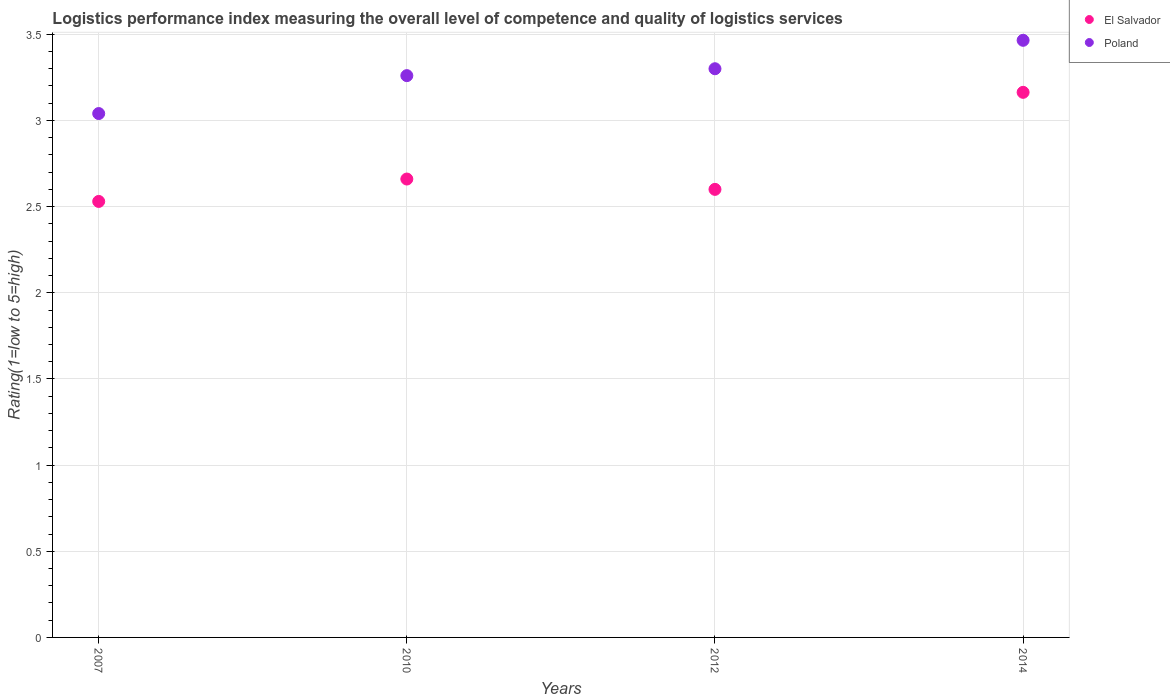Is the number of dotlines equal to the number of legend labels?
Ensure brevity in your answer.  Yes. What is the Logistic performance index in El Salvador in 2007?
Your response must be concise. 2.53. Across all years, what is the maximum Logistic performance index in Poland?
Provide a short and direct response. 3.47. Across all years, what is the minimum Logistic performance index in Poland?
Provide a succinct answer. 3.04. In which year was the Logistic performance index in El Salvador maximum?
Your response must be concise. 2014. In which year was the Logistic performance index in El Salvador minimum?
Make the answer very short. 2007. What is the total Logistic performance index in Poland in the graph?
Your answer should be compact. 13.07. What is the difference between the Logistic performance index in Poland in 2007 and that in 2012?
Your answer should be compact. -0.26. What is the difference between the Logistic performance index in El Salvador in 2010 and the Logistic performance index in Poland in 2007?
Your answer should be very brief. -0.38. What is the average Logistic performance index in El Salvador per year?
Your answer should be compact. 2.74. In the year 2014, what is the difference between the Logistic performance index in Poland and Logistic performance index in El Salvador?
Your response must be concise. 0.3. In how many years, is the Logistic performance index in El Salvador greater than 1.7?
Provide a succinct answer. 4. What is the ratio of the Logistic performance index in El Salvador in 2007 to that in 2014?
Your answer should be very brief. 0.8. Is the Logistic performance index in El Salvador in 2007 less than that in 2012?
Ensure brevity in your answer.  Yes. Is the difference between the Logistic performance index in Poland in 2012 and 2014 greater than the difference between the Logistic performance index in El Salvador in 2012 and 2014?
Your answer should be very brief. Yes. What is the difference between the highest and the second highest Logistic performance index in El Salvador?
Offer a terse response. 0.5. What is the difference between the highest and the lowest Logistic performance index in El Salvador?
Offer a terse response. 0.63. In how many years, is the Logistic performance index in El Salvador greater than the average Logistic performance index in El Salvador taken over all years?
Make the answer very short. 1. Is the sum of the Logistic performance index in Poland in 2010 and 2014 greater than the maximum Logistic performance index in El Salvador across all years?
Keep it short and to the point. Yes. How many dotlines are there?
Your answer should be very brief. 2. How many years are there in the graph?
Offer a terse response. 4. Are the values on the major ticks of Y-axis written in scientific E-notation?
Keep it short and to the point. No. Does the graph contain any zero values?
Offer a very short reply. No. Where does the legend appear in the graph?
Give a very brief answer. Top right. How are the legend labels stacked?
Your answer should be very brief. Vertical. What is the title of the graph?
Your answer should be very brief. Logistics performance index measuring the overall level of competence and quality of logistics services. What is the label or title of the X-axis?
Ensure brevity in your answer.  Years. What is the label or title of the Y-axis?
Keep it short and to the point. Rating(1=low to 5=high). What is the Rating(1=low to 5=high) in El Salvador in 2007?
Your answer should be compact. 2.53. What is the Rating(1=low to 5=high) in Poland in 2007?
Your answer should be very brief. 3.04. What is the Rating(1=low to 5=high) of El Salvador in 2010?
Keep it short and to the point. 2.66. What is the Rating(1=low to 5=high) in Poland in 2010?
Keep it short and to the point. 3.26. What is the Rating(1=low to 5=high) in Poland in 2012?
Offer a very short reply. 3.3. What is the Rating(1=low to 5=high) in El Salvador in 2014?
Provide a short and direct response. 3.16. What is the Rating(1=low to 5=high) of Poland in 2014?
Offer a very short reply. 3.47. Across all years, what is the maximum Rating(1=low to 5=high) in El Salvador?
Give a very brief answer. 3.16. Across all years, what is the maximum Rating(1=low to 5=high) of Poland?
Your answer should be compact. 3.47. Across all years, what is the minimum Rating(1=low to 5=high) of El Salvador?
Keep it short and to the point. 2.53. Across all years, what is the minimum Rating(1=low to 5=high) in Poland?
Ensure brevity in your answer.  3.04. What is the total Rating(1=low to 5=high) of El Salvador in the graph?
Your answer should be compact. 10.95. What is the total Rating(1=low to 5=high) of Poland in the graph?
Your answer should be very brief. 13.06. What is the difference between the Rating(1=low to 5=high) in El Salvador in 2007 and that in 2010?
Give a very brief answer. -0.13. What is the difference between the Rating(1=low to 5=high) in Poland in 2007 and that in 2010?
Ensure brevity in your answer.  -0.22. What is the difference between the Rating(1=low to 5=high) in El Salvador in 2007 and that in 2012?
Give a very brief answer. -0.07. What is the difference between the Rating(1=low to 5=high) of Poland in 2007 and that in 2012?
Your answer should be very brief. -0.26. What is the difference between the Rating(1=low to 5=high) of El Salvador in 2007 and that in 2014?
Provide a short and direct response. -0.63. What is the difference between the Rating(1=low to 5=high) of Poland in 2007 and that in 2014?
Make the answer very short. -0.42. What is the difference between the Rating(1=low to 5=high) in El Salvador in 2010 and that in 2012?
Your answer should be very brief. 0.06. What is the difference between the Rating(1=low to 5=high) of Poland in 2010 and that in 2012?
Your response must be concise. -0.04. What is the difference between the Rating(1=low to 5=high) of El Salvador in 2010 and that in 2014?
Offer a terse response. -0.5. What is the difference between the Rating(1=low to 5=high) in Poland in 2010 and that in 2014?
Provide a succinct answer. -0.2. What is the difference between the Rating(1=low to 5=high) of El Salvador in 2012 and that in 2014?
Make the answer very short. -0.56. What is the difference between the Rating(1=low to 5=high) of Poland in 2012 and that in 2014?
Offer a terse response. -0.17. What is the difference between the Rating(1=low to 5=high) in El Salvador in 2007 and the Rating(1=low to 5=high) in Poland in 2010?
Your response must be concise. -0.73. What is the difference between the Rating(1=low to 5=high) of El Salvador in 2007 and the Rating(1=low to 5=high) of Poland in 2012?
Keep it short and to the point. -0.77. What is the difference between the Rating(1=low to 5=high) in El Salvador in 2007 and the Rating(1=low to 5=high) in Poland in 2014?
Offer a terse response. -0.94. What is the difference between the Rating(1=low to 5=high) in El Salvador in 2010 and the Rating(1=low to 5=high) in Poland in 2012?
Your answer should be very brief. -0.64. What is the difference between the Rating(1=low to 5=high) of El Salvador in 2010 and the Rating(1=low to 5=high) of Poland in 2014?
Ensure brevity in your answer.  -0.81. What is the difference between the Rating(1=low to 5=high) of El Salvador in 2012 and the Rating(1=low to 5=high) of Poland in 2014?
Provide a succinct answer. -0.86. What is the average Rating(1=low to 5=high) of El Salvador per year?
Keep it short and to the point. 2.74. What is the average Rating(1=low to 5=high) of Poland per year?
Offer a very short reply. 3.27. In the year 2007, what is the difference between the Rating(1=low to 5=high) of El Salvador and Rating(1=low to 5=high) of Poland?
Offer a terse response. -0.51. In the year 2014, what is the difference between the Rating(1=low to 5=high) of El Salvador and Rating(1=low to 5=high) of Poland?
Ensure brevity in your answer.  -0.3. What is the ratio of the Rating(1=low to 5=high) of El Salvador in 2007 to that in 2010?
Offer a terse response. 0.95. What is the ratio of the Rating(1=low to 5=high) in Poland in 2007 to that in 2010?
Make the answer very short. 0.93. What is the ratio of the Rating(1=low to 5=high) in El Salvador in 2007 to that in 2012?
Ensure brevity in your answer.  0.97. What is the ratio of the Rating(1=low to 5=high) of Poland in 2007 to that in 2012?
Make the answer very short. 0.92. What is the ratio of the Rating(1=low to 5=high) in El Salvador in 2007 to that in 2014?
Make the answer very short. 0.8. What is the ratio of the Rating(1=low to 5=high) of Poland in 2007 to that in 2014?
Ensure brevity in your answer.  0.88. What is the ratio of the Rating(1=low to 5=high) of El Salvador in 2010 to that in 2012?
Make the answer very short. 1.02. What is the ratio of the Rating(1=low to 5=high) in Poland in 2010 to that in 2012?
Your answer should be very brief. 0.99. What is the ratio of the Rating(1=low to 5=high) of El Salvador in 2010 to that in 2014?
Offer a very short reply. 0.84. What is the ratio of the Rating(1=low to 5=high) in Poland in 2010 to that in 2014?
Offer a terse response. 0.94. What is the ratio of the Rating(1=low to 5=high) in El Salvador in 2012 to that in 2014?
Make the answer very short. 0.82. What is the difference between the highest and the second highest Rating(1=low to 5=high) in El Salvador?
Offer a very short reply. 0.5. What is the difference between the highest and the second highest Rating(1=low to 5=high) in Poland?
Give a very brief answer. 0.17. What is the difference between the highest and the lowest Rating(1=low to 5=high) of El Salvador?
Keep it short and to the point. 0.63. What is the difference between the highest and the lowest Rating(1=low to 5=high) of Poland?
Offer a very short reply. 0.42. 